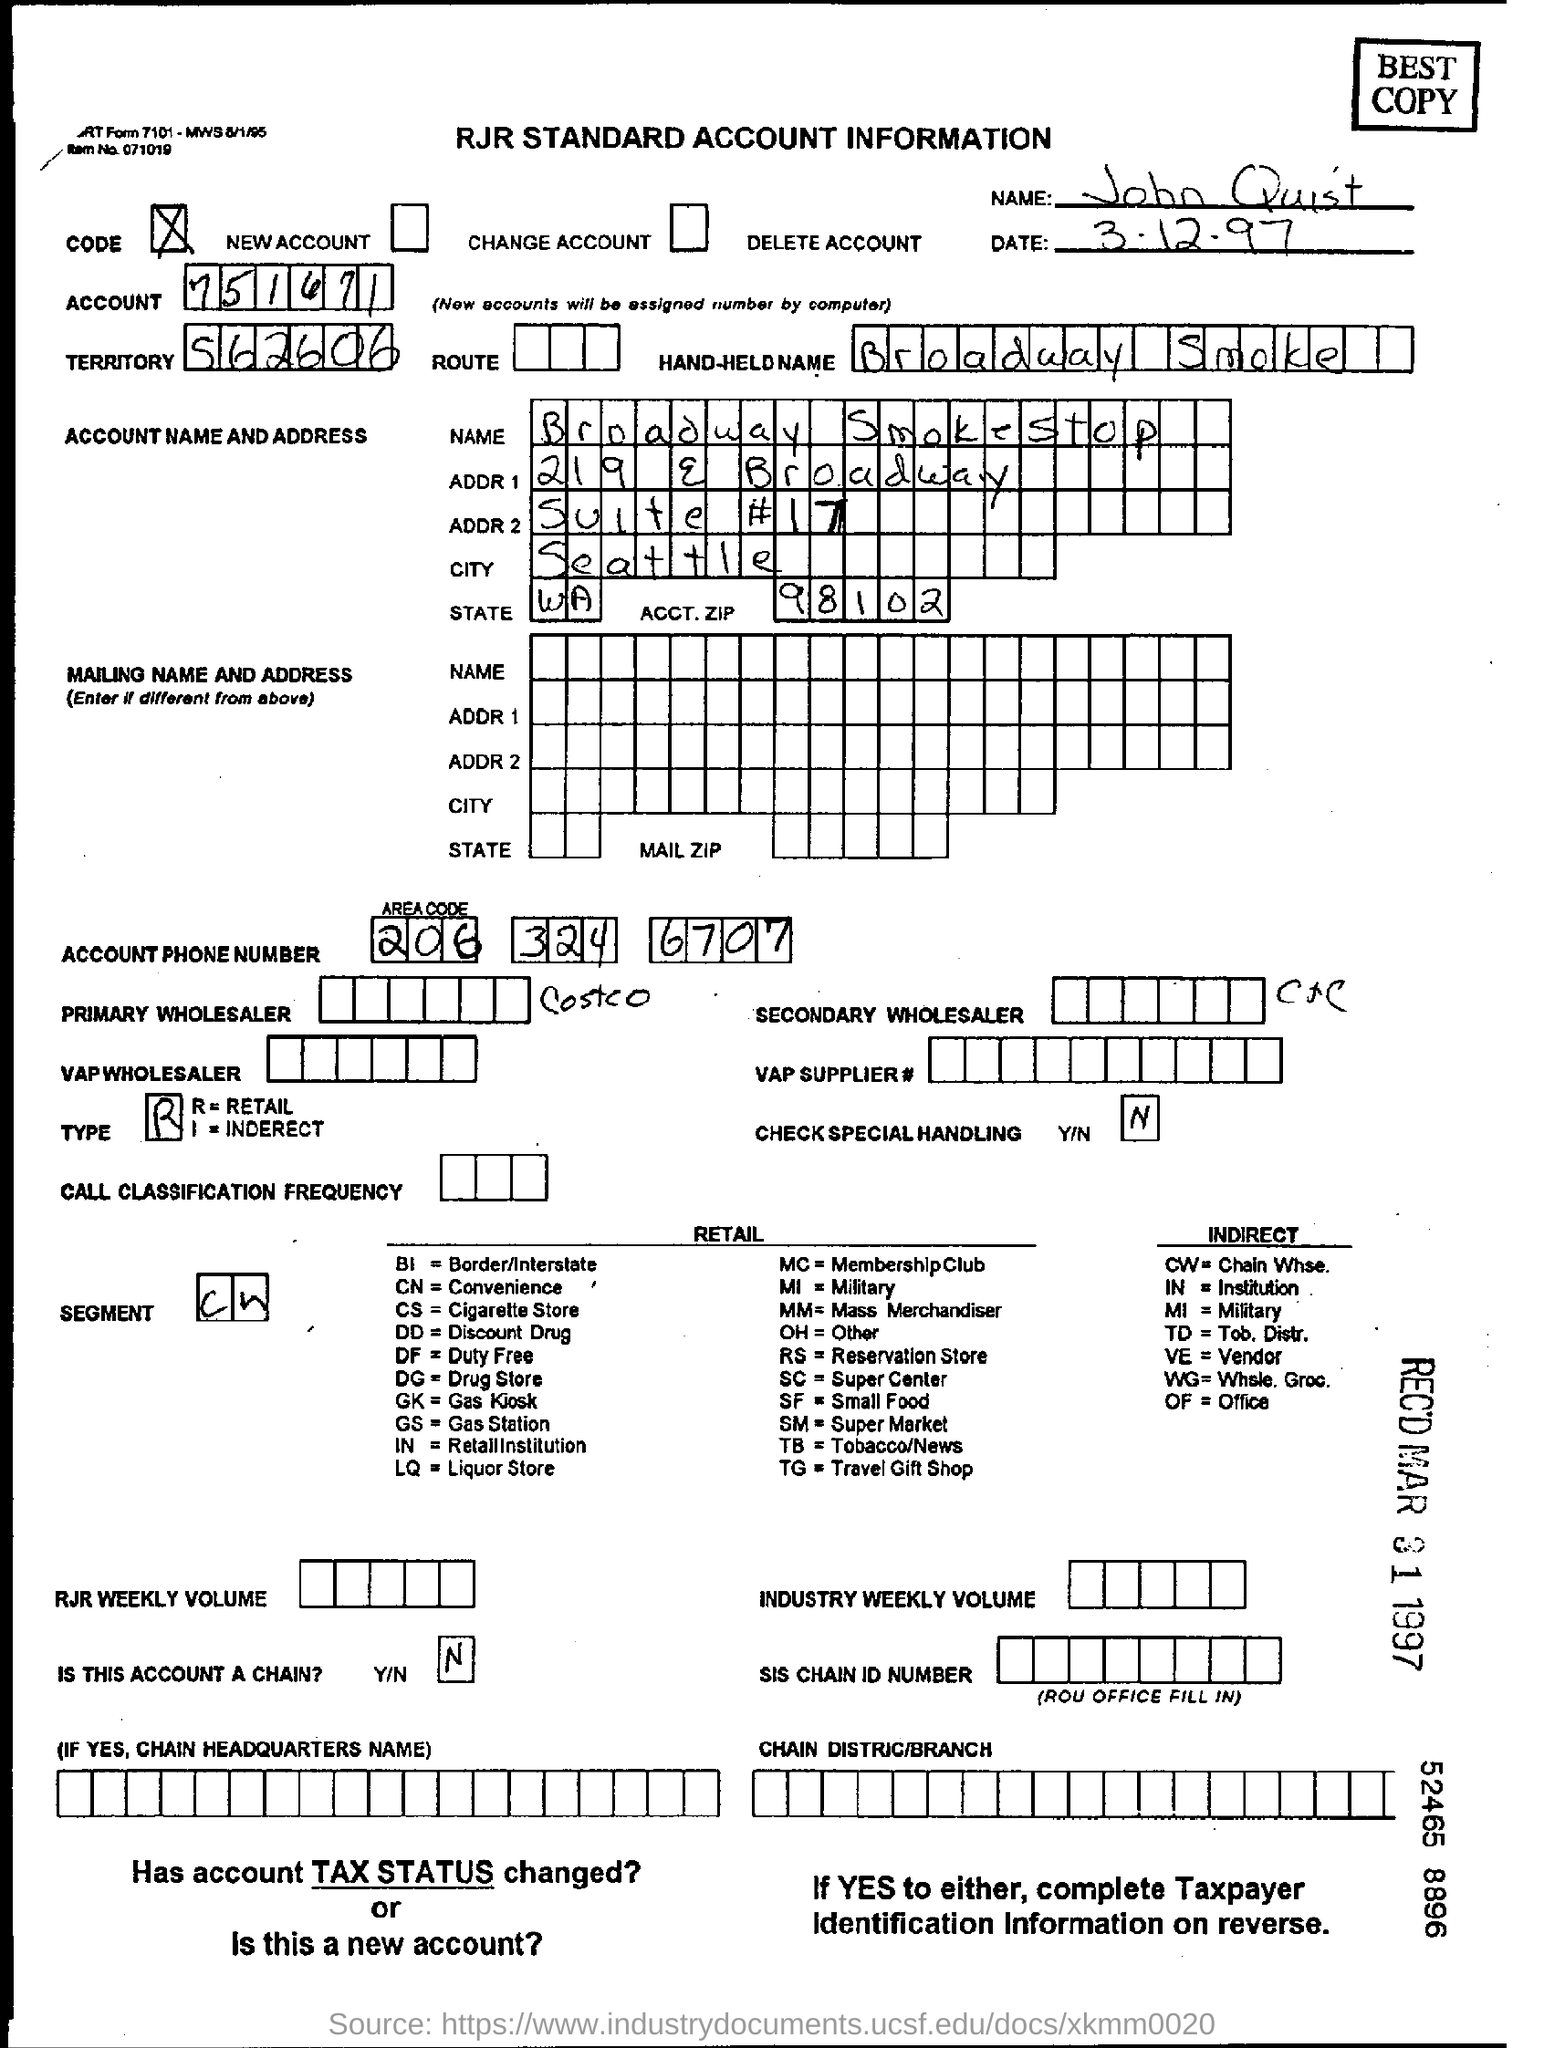Which is the HAND-HELD NAME mentioned?
Make the answer very short. Broadway Smoke. What is the name mentioned in the form?
Offer a terse response. John Quist. 